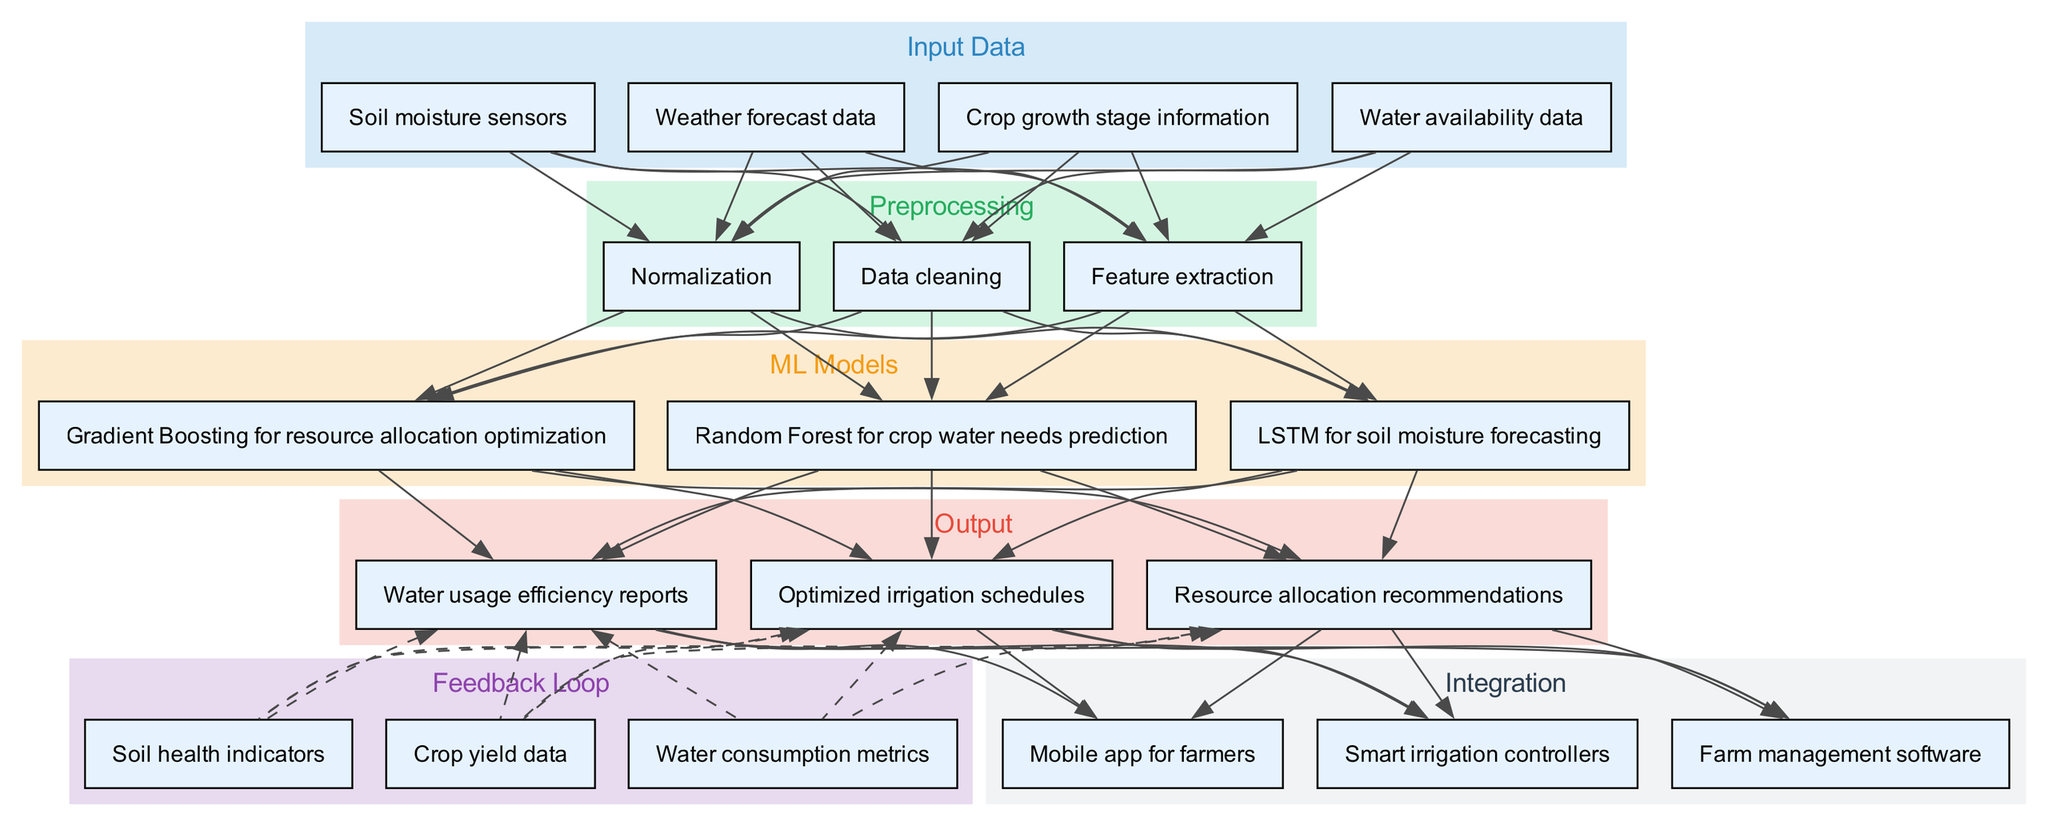What are the input data sources used in the system? The diagram indicates four input data sources: soil moisture sensors, weather forecast data, crop growth stage information, and water availability data.
Answer: Soil moisture sensors, weather forecast data, crop growth stage information, water availability data How many ML models are defined in the diagram? The diagram displays three distinct ML models: Random Forest, LSTM, and Gradient Boosting, indicating a count of three.
Answer: Three What is the relationship between preprocessing and ML models? The diagram illustrates a direct link where each preprocessing step connects to every ML model, indicating that all models rely on the outcomes of the preprocessing phase.
Answer: All models receive preprocessing outputs What feedback metrics are utilized in the feedback loop? The feedback loop includes crop yield data, water consumption metrics, and soil health indicators, providing three specific metrics.
Answer: Crop yield data, water consumption metrics, soil health indicators Which ML model is used for soil moisture forecasting? The diagram specifies LSTM as the model tasked with soil moisture forecasting, indicating its unique role within the ML models section.
Answer: LSTM How do the outputs connect to the integration phase? The diagram shows that each output—optimized irrigation schedules, resource allocation recommendations, and water usage efficiency reports—feeds into integration components, highlighting a clear path from outputs to integrations.
Answer: All outputs are connected to integration components What type of irrigation solution is integrated at the end? The integration phase reveals that smart irrigation controllers are part of the system, demonstrating a technology incorporation aimed at improving irrigation practices.
Answer: Smart irrigation controllers Which preprocessing method comes after data cleaning? The diagram lists feature extraction as the next preprocessing step following data cleaning, presenting a linear flow of activities within the preprocessing section.
Answer: Feature extraction What is the final output type specified in the diagram? The last output mentioned is water usage efficiency reports, highlighting its position as the concluding outcome in the flow of outputs.
Answer: Water usage efficiency reports 